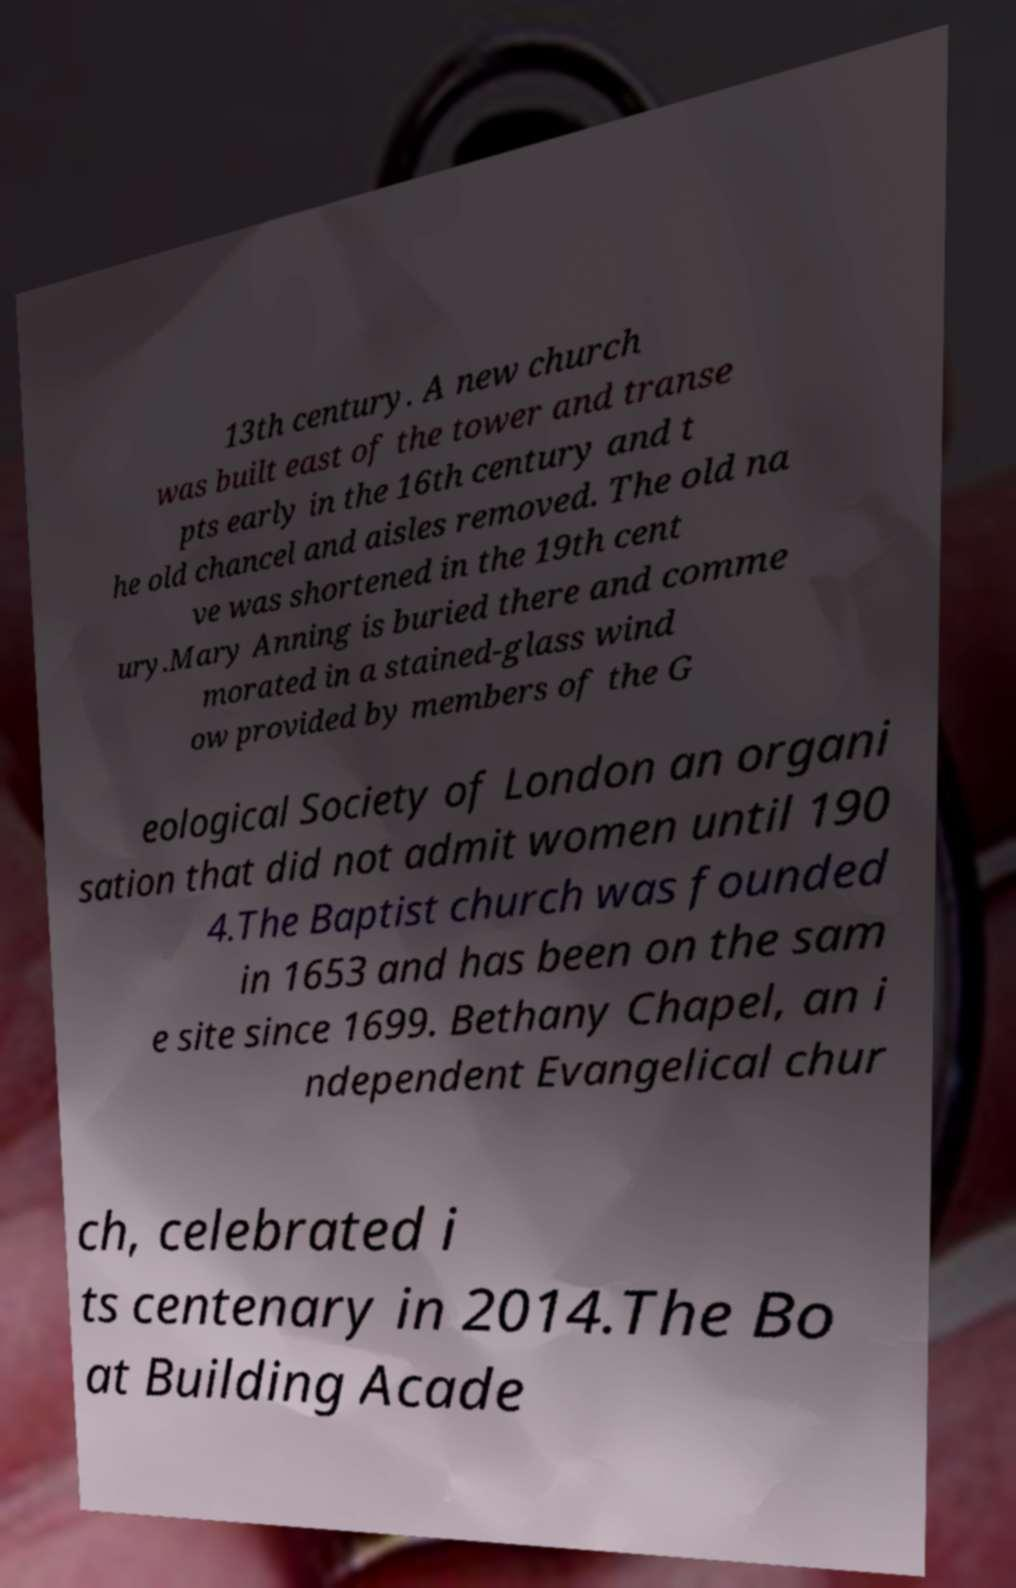Could you assist in decoding the text presented in this image and type it out clearly? 13th century. A new church was built east of the tower and transe pts early in the 16th century and t he old chancel and aisles removed. The old na ve was shortened in the 19th cent ury.Mary Anning is buried there and comme morated in a stained-glass wind ow provided by members of the G eological Society of London an organi sation that did not admit women until 190 4.The Baptist church was founded in 1653 and has been on the sam e site since 1699. Bethany Chapel, an i ndependent Evangelical chur ch, celebrated i ts centenary in 2014.The Bo at Building Acade 